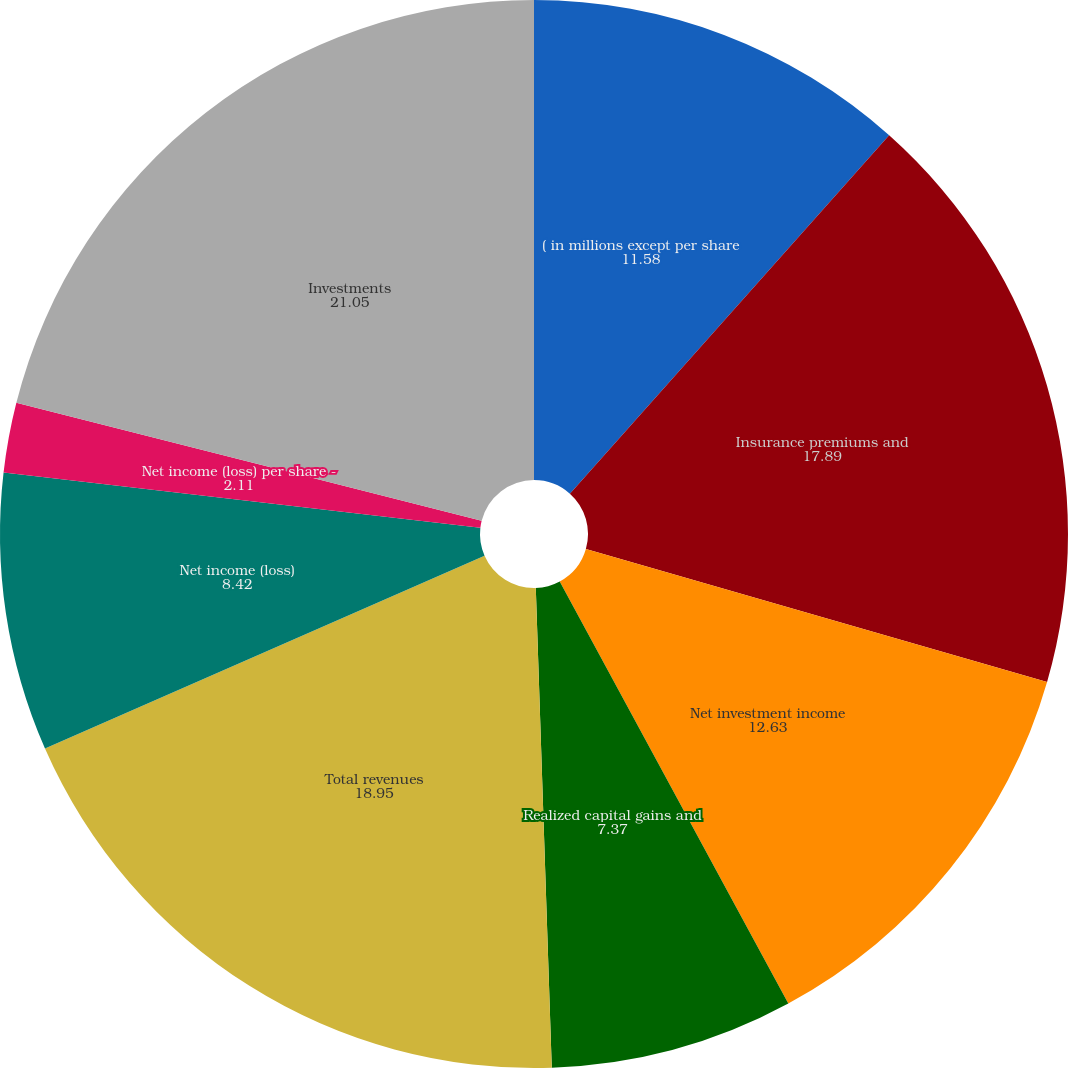<chart> <loc_0><loc_0><loc_500><loc_500><pie_chart><fcel>( in millions except per share<fcel>Insurance premiums and<fcel>Net investment income<fcel>Realized capital gains and<fcel>Total revenues<fcel>Net income (loss)<fcel>Net income (loss) per share -<fcel>Cash dividends declared per<fcel>Investments<nl><fcel>11.58%<fcel>17.89%<fcel>12.63%<fcel>7.37%<fcel>18.95%<fcel>8.42%<fcel>2.11%<fcel>0.0%<fcel>21.05%<nl></chart> 